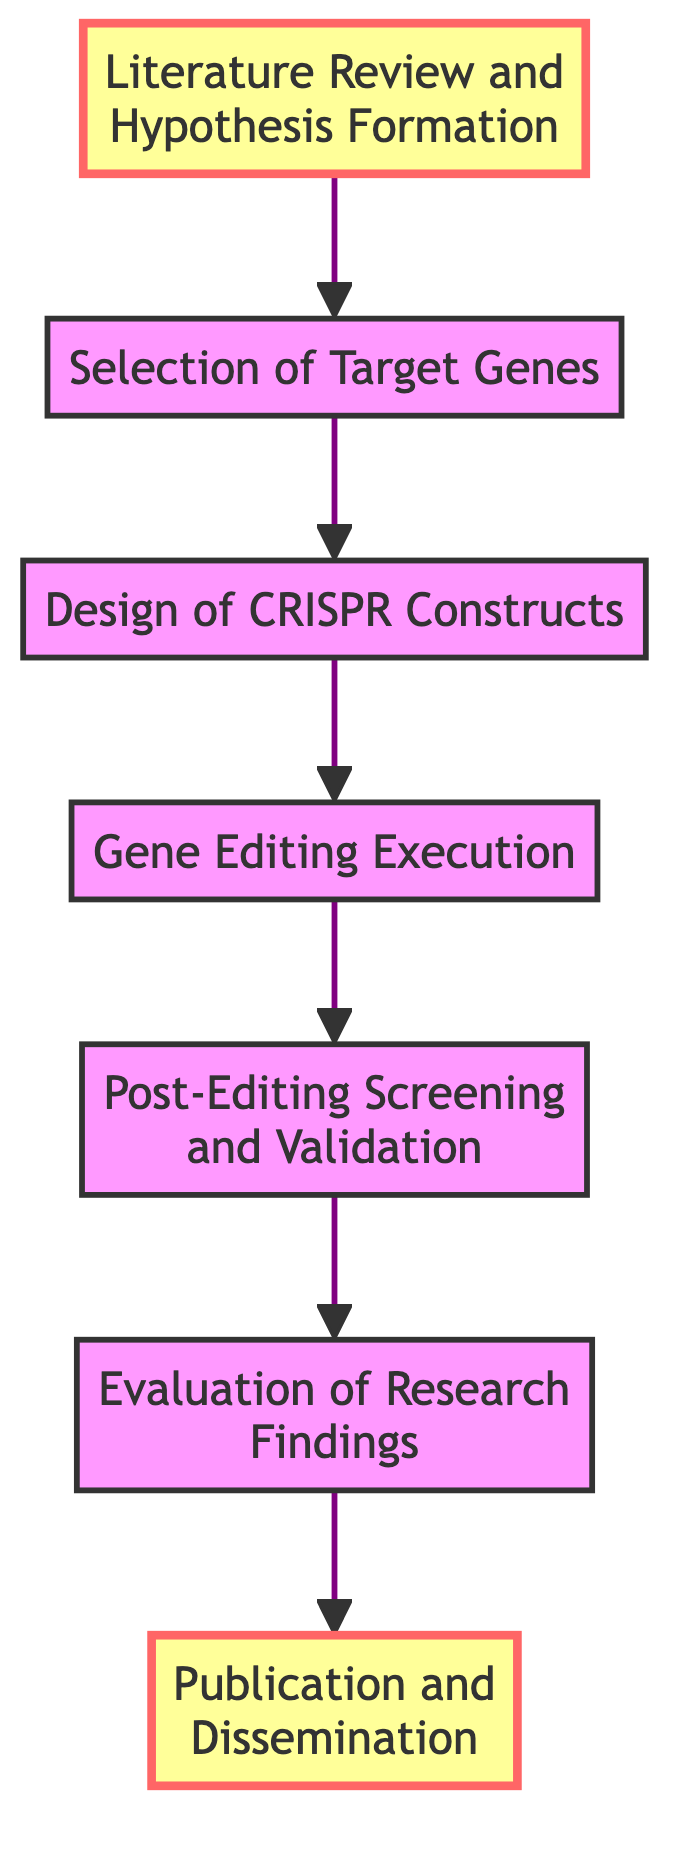What is the first step in the gene editing workflow? The first step in the workflow is found at the bottom of the diagram, which indicates that "Literature Review and Hypothesis Formation" is the starting point before any gene editing processes begin.
Answer: Literature Review and Hypothesis Formation How many nodes are there in the diagram? By counting the individual elements listed in the diagram, there are a total of seven distinct nodes that represent the various steps of the gene editing workflow.
Answer: 7 What is the last step in the evaluation process? The last step in the diagram is "Publication and Dissemination," which signifies the final stage where the research findings are shared with the broader scientific community after evaluation.
Answer: Publication and Dissemination Which step follows "Gene Editing Execution"? Following the "Gene Editing Execution" step, the diagram shows that the next step is "Post-Editing Screening and Validation," indicating the process of verifying the results of the gene editing.
Answer: Post-Editing Screening and Validation What step is directly connected to "Selection of Target Genes"? The "Design of CRISPR Constructs" step is directly connected to "Selection of Target Genes," indicating that after selecting the genes, the next task is to design the necessary constructs for editing.
Answer: Design of CRISPR Constructs Which steps are highlighted in the diagram? The diagram highlights "Literature Review and Hypothesis Formation" at the beginning and "Publication and Dissemination" at the end, emphasizing the importance of these two key stages in the research workflow.
Answer: Literature Review and Hypothesis Formation, Publication and Dissemination What is the relationship between "Evaluation of Research Findings" and "Post-Editing Screening and Validation"? The relationship is sequential; "Post-Editing Screening and Validation" must occur before the "Evaluation of Research Findings," signifying that findings are assessed after validation.
Answer: Sequential relationship What is the primary purpose of the "Design of CRISPR Constructs" step? The primary purpose of this step is to create guide RNA sequences and Cas9 constructs that are specific to the target genes that have been chosen for editing, which is essential for the editing process.
Answer: Creating guide RNA sequences and Cas9 constructs How does the workflow progress from "Literature Review and Hypothesis Formation" to "Evaluation of Research Findings"? The workflow progresses through a series of steps: first forming a hypothesis, then selecting target genes, designing constructs, executing the editing, validating the results, and finally evaluating the research findings at the penultimate step.
Answer: Sequentially through multiple steps 